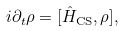<formula> <loc_0><loc_0><loc_500><loc_500>i \partial _ { t } \rho = [ \hat { H } _ { \text {CS} } , \rho ] ,</formula> 